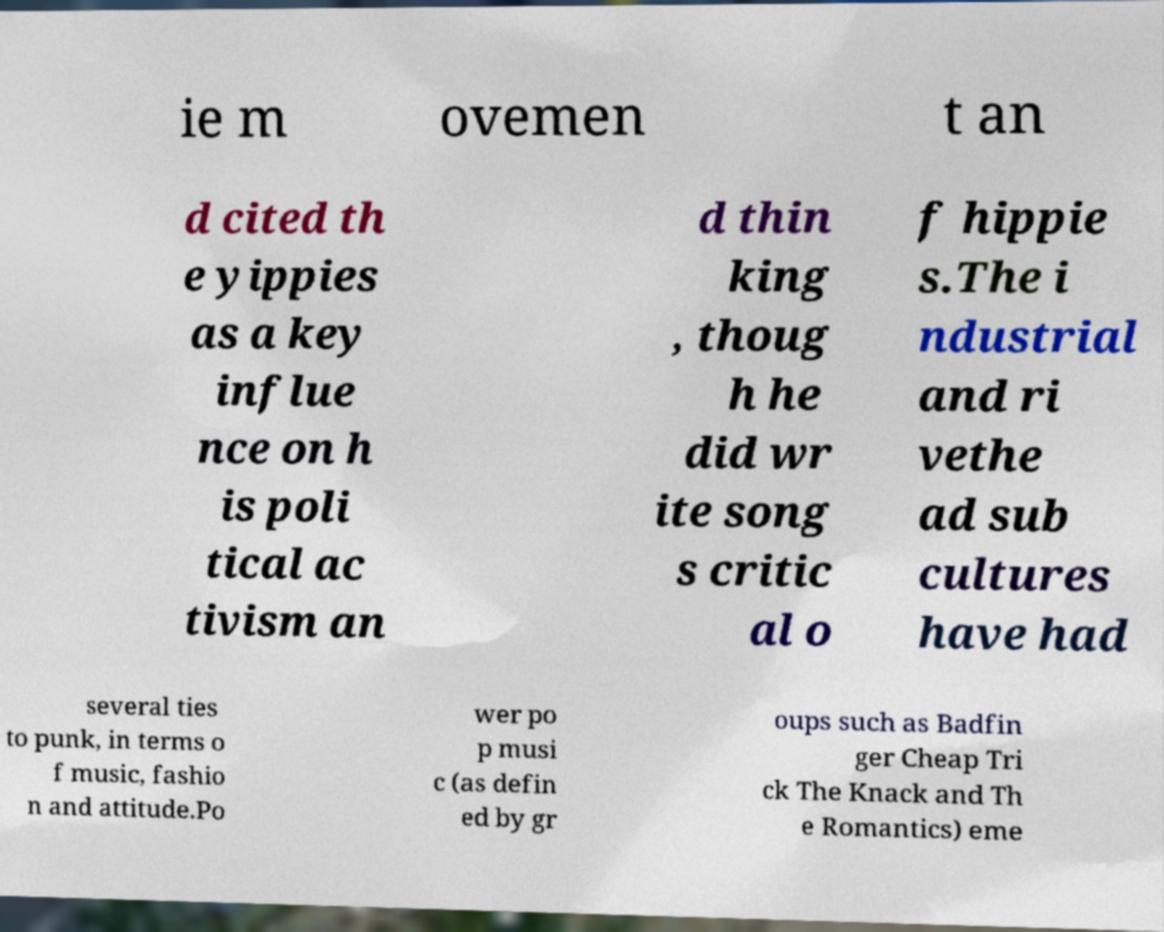I need the written content from this picture converted into text. Can you do that? ie m ovemen t an d cited th e yippies as a key influe nce on h is poli tical ac tivism an d thin king , thoug h he did wr ite song s critic al o f hippie s.The i ndustrial and ri vethe ad sub cultures have had several ties to punk, in terms o f music, fashio n and attitude.Po wer po p musi c (as defin ed by gr oups such as Badfin ger Cheap Tri ck The Knack and Th e Romantics) eme 